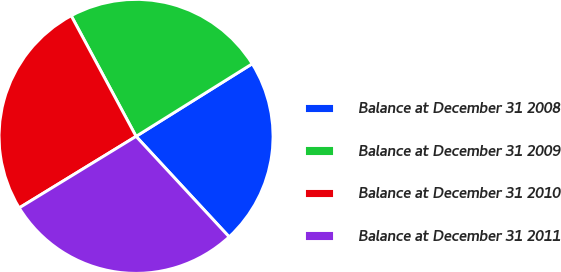Convert chart to OTSL. <chart><loc_0><loc_0><loc_500><loc_500><pie_chart><fcel>Balance at December 31 2008<fcel>Balance at December 31 2009<fcel>Balance at December 31 2010<fcel>Balance at December 31 2011<nl><fcel>22.0%<fcel>23.96%<fcel>25.89%<fcel>28.15%<nl></chart> 